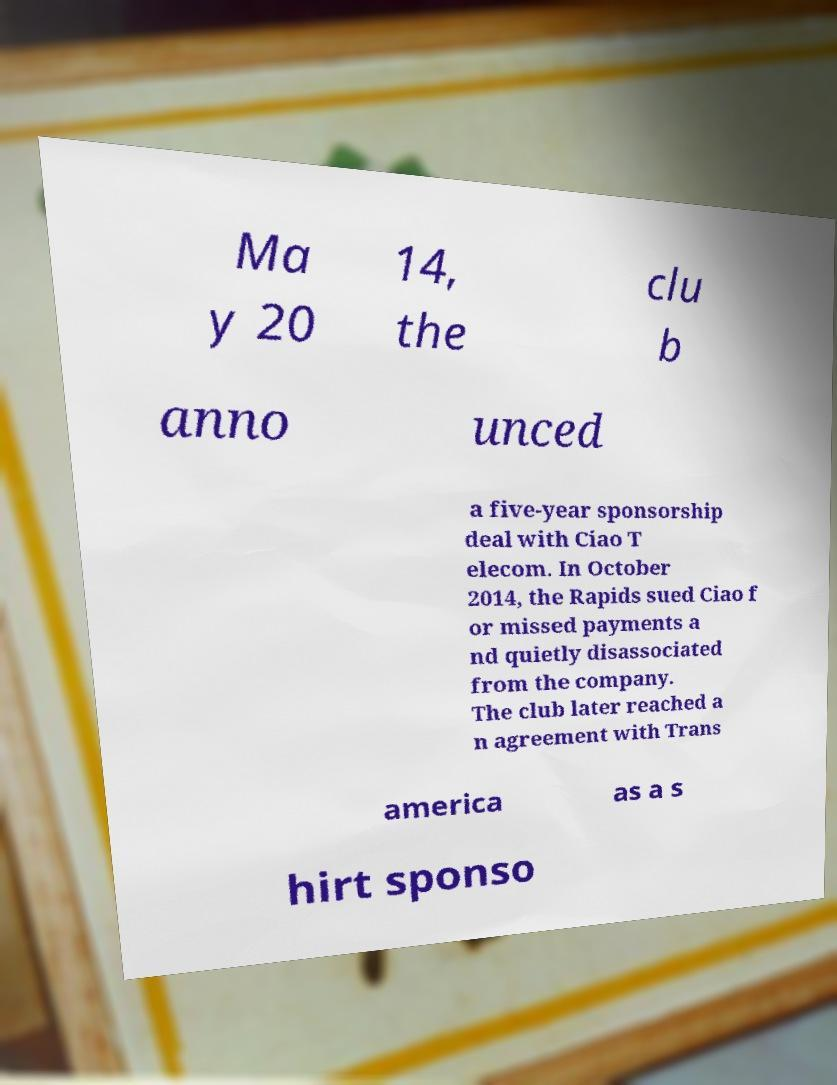Could you assist in decoding the text presented in this image and type it out clearly? Ma y 20 14, the clu b anno unced a five-year sponsorship deal with Ciao T elecom. In October 2014, the Rapids sued Ciao f or missed payments a nd quietly disassociated from the company. The club later reached a n agreement with Trans america as a s hirt sponso 